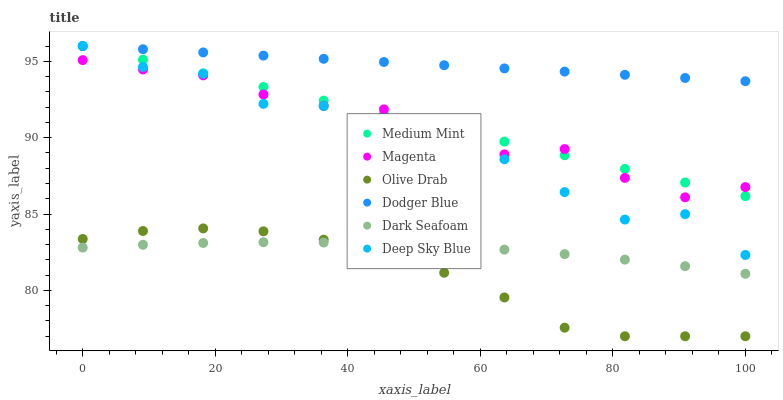Does Olive Drab have the minimum area under the curve?
Answer yes or no. Yes. Does Dodger Blue have the maximum area under the curve?
Answer yes or no. Yes. Does Dark Seafoam have the minimum area under the curve?
Answer yes or no. No. Does Dark Seafoam have the maximum area under the curve?
Answer yes or no. No. Is Dodger Blue the smoothest?
Answer yes or no. Yes. Is Deep Sky Blue the roughest?
Answer yes or no. Yes. Is Dark Seafoam the smoothest?
Answer yes or no. No. Is Dark Seafoam the roughest?
Answer yes or no. No. Does Olive Drab have the lowest value?
Answer yes or no. Yes. Does Dark Seafoam have the lowest value?
Answer yes or no. No. Does Deep Sky Blue have the highest value?
Answer yes or no. Yes. Does Dark Seafoam have the highest value?
Answer yes or no. No. Is Dark Seafoam less than Deep Sky Blue?
Answer yes or no. Yes. Is Magenta greater than Olive Drab?
Answer yes or no. Yes. Does Medium Mint intersect Dodger Blue?
Answer yes or no. Yes. Is Medium Mint less than Dodger Blue?
Answer yes or no. No. Is Medium Mint greater than Dodger Blue?
Answer yes or no. No. Does Dark Seafoam intersect Deep Sky Blue?
Answer yes or no. No. 